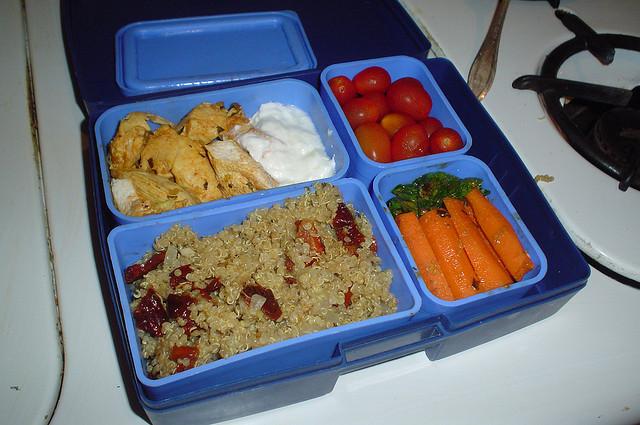Does this look like a healthy lunch?
Short answer required. Yes. How many different types of food are there?
Quick response, please. 6. What utensil is in the right section of the lunch box?
Be succinct. Fork. What kind of fruit is this?
Write a very short answer. Tomato. How many squares are in this picture?
Answer briefly. 4. How many veggies are shown?
Answer briefly. 2. Where are the carrots?
Concise answer only. Right bottom of container. What is the purpose of lining the pan?
Short answer required. Cleanliness. 